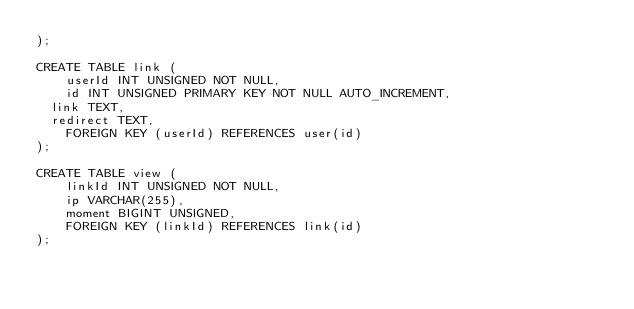Convert code to text. <code><loc_0><loc_0><loc_500><loc_500><_SQL_>);

CREATE TABLE link (
    userId INT UNSIGNED NOT NULL,
    id INT UNSIGNED PRIMARY KEY NOT NULL AUTO_INCREMENT,
	link TEXT,
	redirect TEXT,
    FOREIGN KEY (userId) REFERENCES user(id)
);

CREATE TABLE view (
    linkId INT UNSIGNED NOT NULL,
    ip VARCHAR(255),
    moment BIGINT UNSIGNED,
    FOREIGN KEY (linkId) REFERENCES link(id)
);</code> 